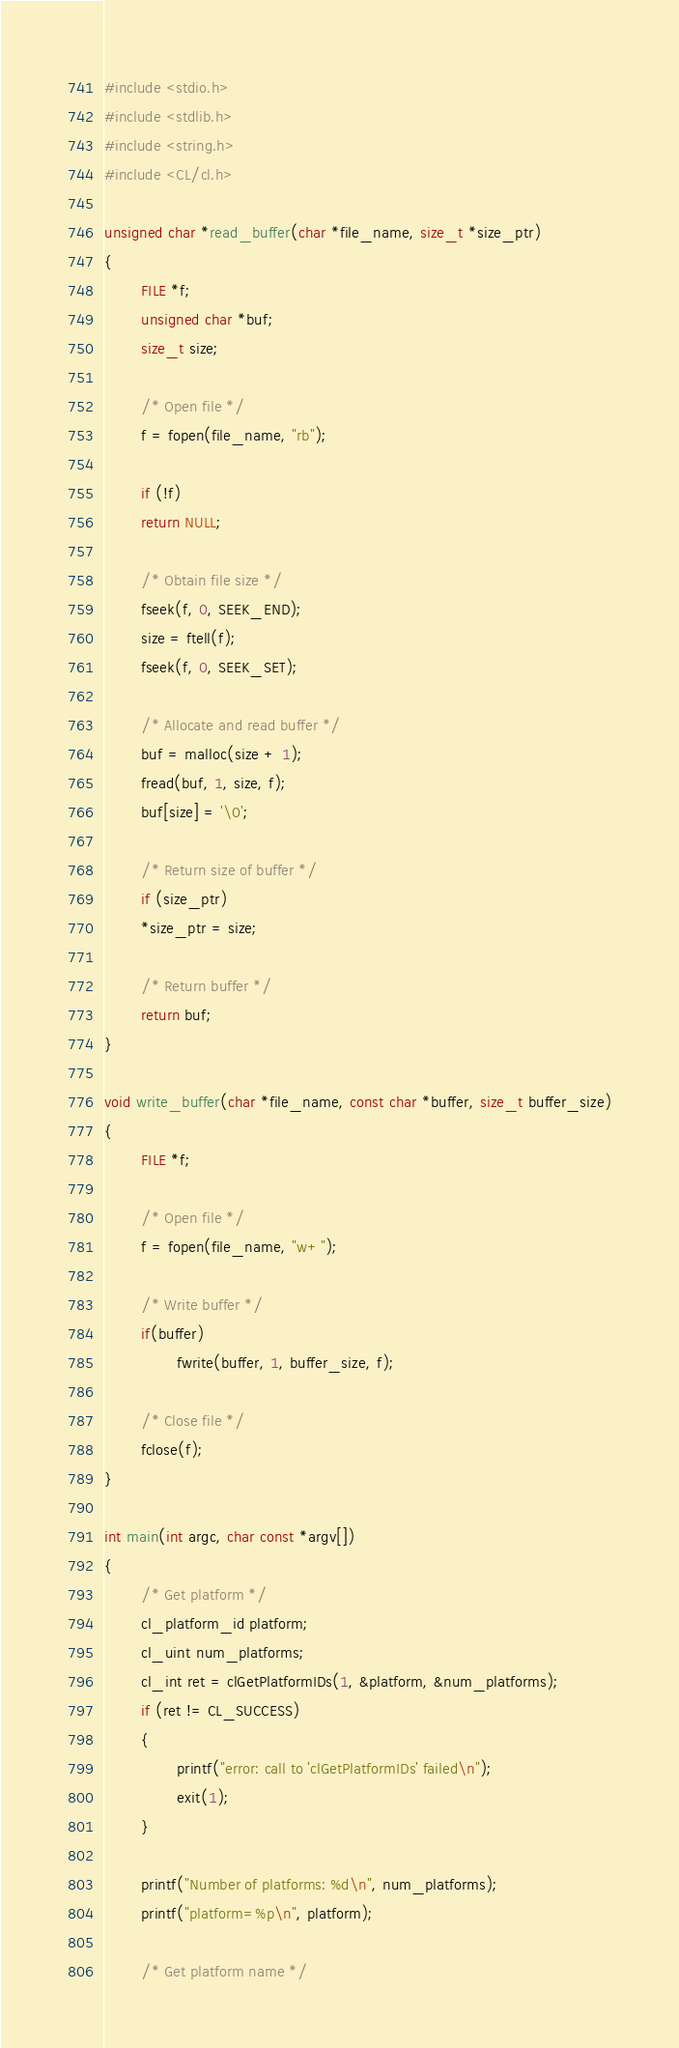<code> <loc_0><loc_0><loc_500><loc_500><_C_>#include <stdio.h>
#include <stdlib.h>
#include <string.h>
#include <CL/cl.h>

unsigned char *read_buffer(char *file_name, size_t *size_ptr)
{
        FILE *f;
        unsigned char *buf;
        size_t size;

        /* Open file */
        f = fopen(file_name, "rb");

        if (!f)
        return NULL;

        /* Obtain file size */
        fseek(f, 0, SEEK_END);
        size = ftell(f);
        fseek(f, 0, SEEK_SET);

        /* Allocate and read buffer */
        buf = malloc(size + 1);
        fread(buf, 1, size, f);
        buf[size] = '\0';

        /* Return size of buffer */
        if (size_ptr)
        *size_ptr = size;

        /* Return buffer */
        return buf;
}

void write_buffer(char *file_name, const char *buffer, size_t buffer_size)
{
        FILE *f;

        /* Open file */
        f = fopen(file_name, "w+");

        /* Write buffer */
        if(buffer)
                fwrite(buffer, 1, buffer_size, f);

        /* Close file */
        fclose(f);
}

int main(int argc, char const *argv[])
{
        /* Get platform */
        cl_platform_id platform;
        cl_uint num_platforms;
        cl_int ret = clGetPlatformIDs(1, &platform, &num_platforms);
        if (ret != CL_SUCCESS)
        {
                printf("error: call to 'clGetPlatformIDs' failed\n");
                exit(1);
        }
        
        printf("Number of platforms: %d\n", num_platforms);
        printf("platform=%p\n", platform);
        
        /* Get platform name */</code> 